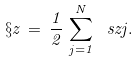Convert formula to latex. <formula><loc_0><loc_0><loc_500><loc_500>\S z \, = \, \frac { 1 } { 2 } \, \sum _ { j = 1 } ^ { N } \ s z { j } .</formula> 